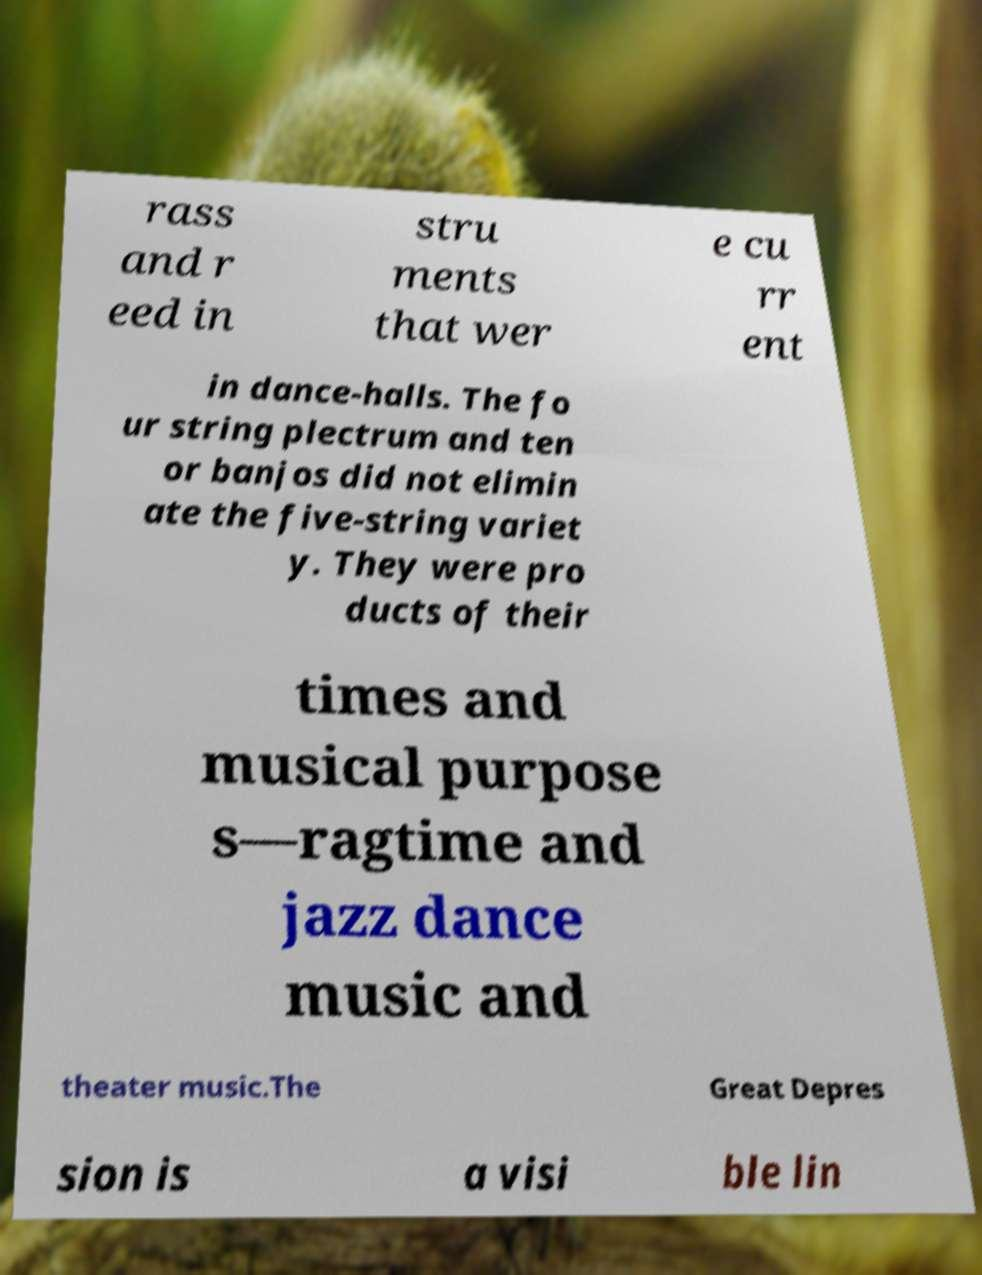Can you accurately transcribe the text from the provided image for me? rass and r eed in stru ments that wer e cu rr ent in dance-halls. The fo ur string plectrum and ten or banjos did not elimin ate the five-string variet y. They were pro ducts of their times and musical purpose s—ragtime and jazz dance music and theater music.The Great Depres sion is a visi ble lin 